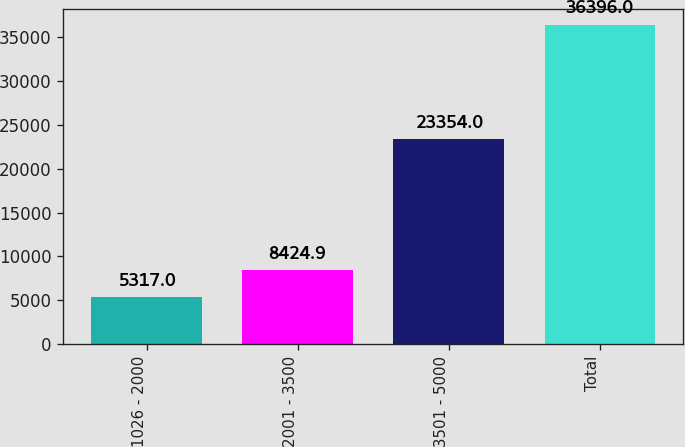Convert chart to OTSL. <chart><loc_0><loc_0><loc_500><loc_500><bar_chart><fcel>1026 - 2000<fcel>2001 - 3500<fcel>3501 - 5000<fcel>Total<nl><fcel>5317<fcel>8424.9<fcel>23354<fcel>36396<nl></chart> 